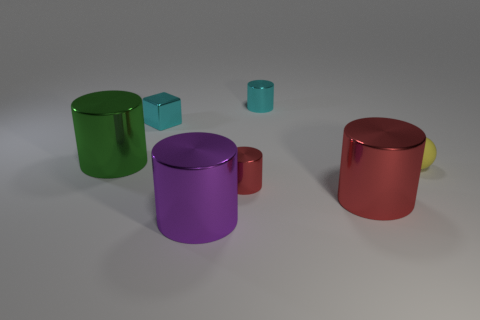Is the number of small red things less than the number of large purple matte objects?
Offer a very short reply. No. How many things are either tiny gray cylinders or big green things?
Your response must be concise. 1. Is the purple metallic thing the same shape as the small rubber thing?
Offer a terse response. No. Is there any other thing that is the same material as the small ball?
Provide a succinct answer. No. Do the cylinder that is behind the green metallic cylinder and the red cylinder in front of the small red thing have the same size?
Offer a terse response. No. There is a thing that is on the right side of the small cyan metal block and left of the tiny red metal object; what is its material?
Offer a terse response. Metal. Are there any other things of the same color as the tiny shiny block?
Offer a terse response. Yes. Is the number of purple cylinders to the right of the purple metal object less than the number of cyan cylinders?
Provide a short and direct response. Yes. Are there more red shiny cylinders than tiny yellow balls?
Offer a terse response. Yes. There is a cylinder behind the large cylinder that is to the left of the small shiny cube; are there any tiny cyan blocks that are on the right side of it?
Give a very brief answer. No. 